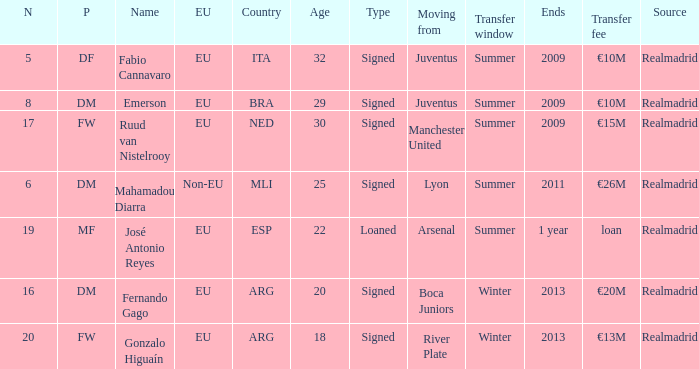What is the EU status of ESP? EU. 